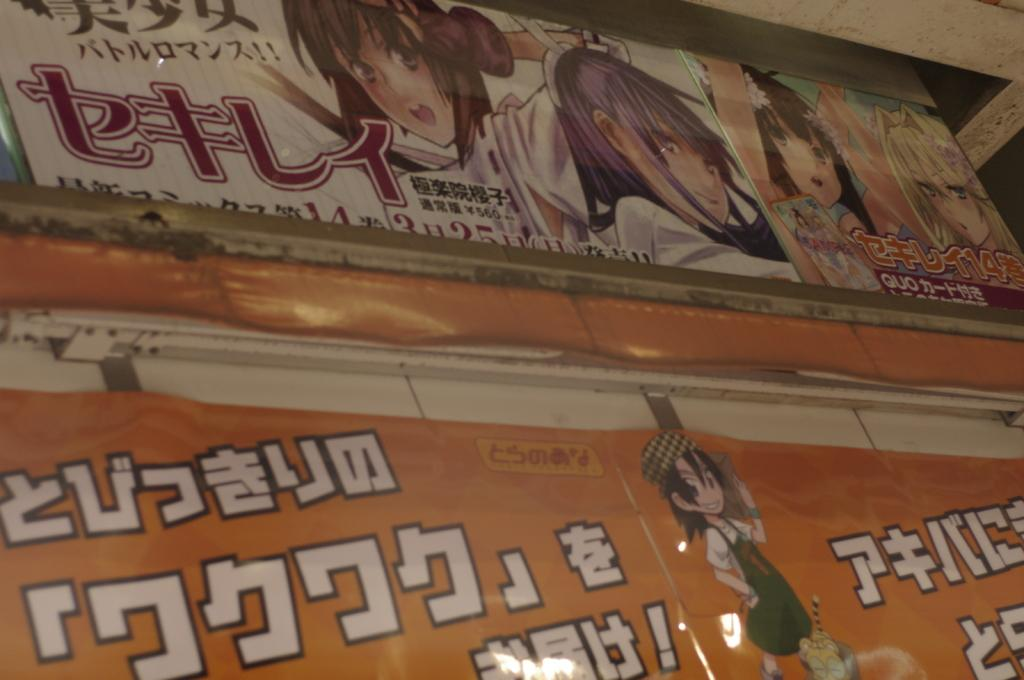How many posters are in the image? There are two posters in the image. What can be found on the posters? The posters have text and cartoons on them. Where are the posters located in the image? The posters are on the wall. What type of skin condition can be seen on the posters in the image? There is no skin condition present on the posters in the image; they have text and cartoons on them. 